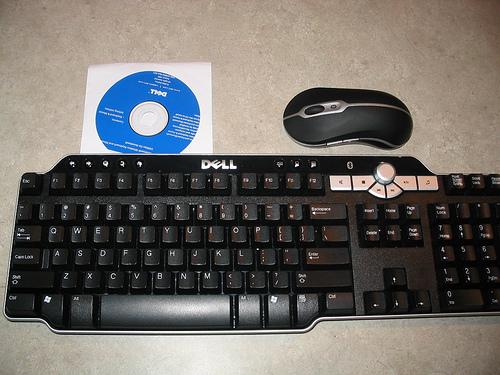Is there a mouse in this picture?
Be succinct. Yes. What color is the disc?
Short answer required. Blue. What brand of keyboard is this?
Be succinct. Dell. 